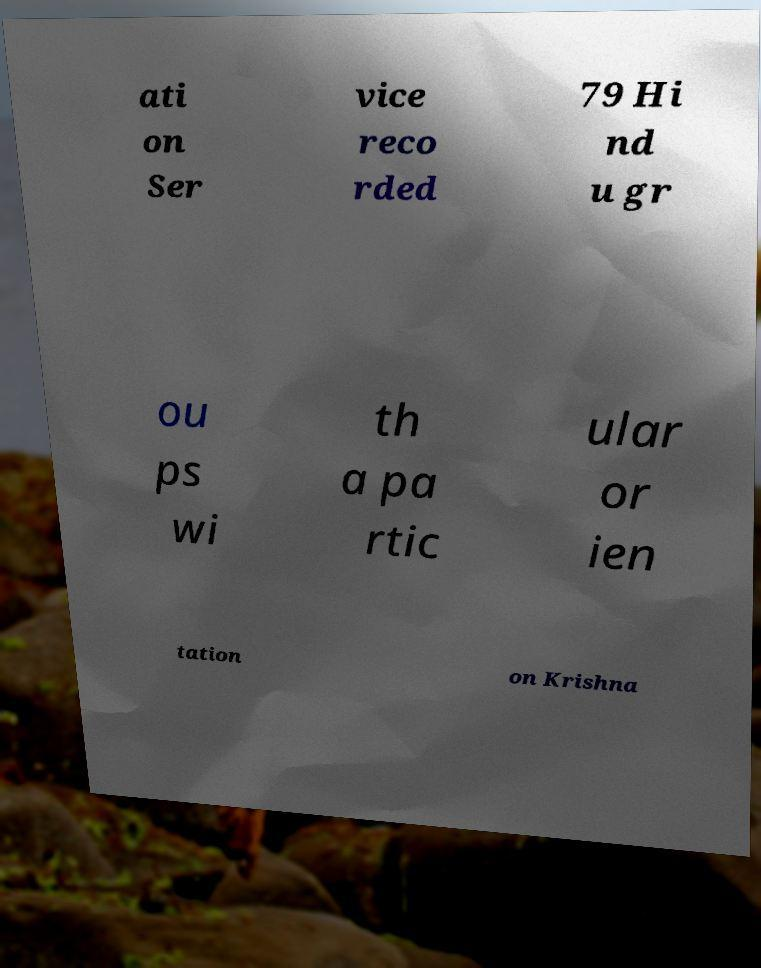For documentation purposes, I need the text within this image transcribed. Could you provide that? ati on Ser vice reco rded 79 Hi nd u gr ou ps wi th a pa rtic ular or ien tation on Krishna 